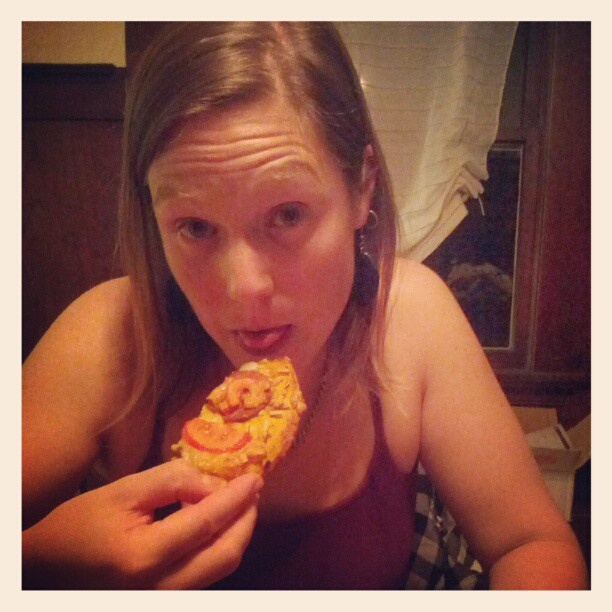Describe the objects in this image and their specific colors. I can see people in ivory, maroon, brown, and black tones and pizza in ivory, orange, red, and salmon tones in this image. 